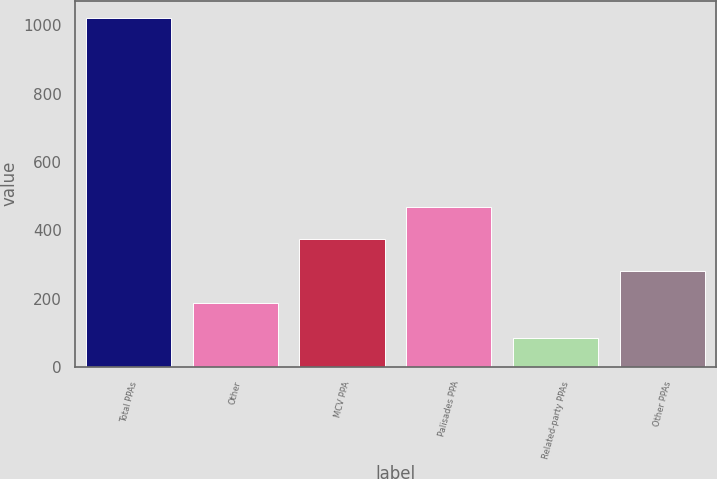Convert chart. <chart><loc_0><loc_0><loc_500><loc_500><bar_chart><fcel>Total PPAs<fcel>Other<fcel>MCV PPA<fcel>Palisades PPA<fcel>Related-party PPAs<fcel>Other PPAs<nl><fcel>1021<fcel>187<fcel>374<fcel>467.5<fcel>86<fcel>280.5<nl></chart> 